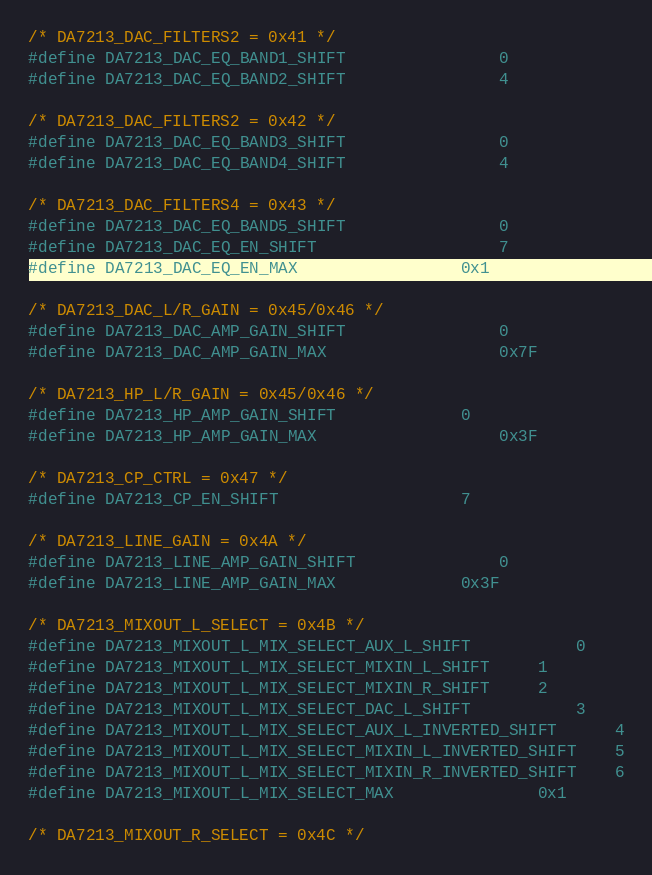<code> <loc_0><loc_0><loc_500><loc_500><_C_>/* DA7213_DAC_FILTERS2 = 0x41 */
#define DA7213_DAC_EQ_BAND1_SHIFT				0
#define DA7213_DAC_EQ_BAND2_SHIFT				4

/* DA7213_DAC_FILTERS2 = 0x42 */
#define DA7213_DAC_EQ_BAND3_SHIFT				0
#define DA7213_DAC_EQ_BAND4_SHIFT				4

/* DA7213_DAC_FILTERS4 = 0x43 */
#define DA7213_DAC_EQ_BAND5_SHIFT				0
#define DA7213_DAC_EQ_EN_SHIFT					7
#define DA7213_DAC_EQ_EN_MAX					0x1

/* DA7213_DAC_L/R_GAIN = 0x45/0x46 */
#define DA7213_DAC_AMP_GAIN_SHIFT				0
#define DA7213_DAC_AMP_GAIN_MAX					0x7F

/* DA7213_HP_L/R_GAIN = 0x45/0x46 */
#define DA7213_HP_AMP_GAIN_SHIFT				0
#define DA7213_HP_AMP_GAIN_MAX					0x3F

/* DA7213_CP_CTRL = 0x47 */
#define DA7213_CP_EN_SHIFT					7

/* DA7213_LINE_GAIN = 0x4A */
#define DA7213_LINE_AMP_GAIN_SHIFT				0
#define DA7213_LINE_AMP_GAIN_MAX				0x3F

/* DA7213_MIXOUT_L_SELECT = 0x4B */
#define DA7213_MIXOUT_L_MIX_SELECT_AUX_L_SHIFT			0
#define DA7213_MIXOUT_L_MIX_SELECT_MIXIN_L_SHIFT		1
#define DA7213_MIXOUT_L_MIX_SELECT_MIXIN_R_SHIFT		2
#define DA7213_MIXOUT_L_MIX_SELECT_DAC_L_SHIFT			3
#define DA7213_MIXOUT_L_MIX_SELECT_AUX_L_INVERTED_SHIFT		4
#define DA7213_MIXOUT_L_MIX_SELECT_MIXIN_L_INVERTED_SHIFT	5
#define DA7213_MIXOUT_L_MIX_SELECT_MIXIN_R_INVERTED_SHIFT	6
#define DA7213_MIXOUT_L_MIX_SELECT_MAX				0x1

/* DA7213_MIXOUT_R_SELECT = 0x4C */</code> 